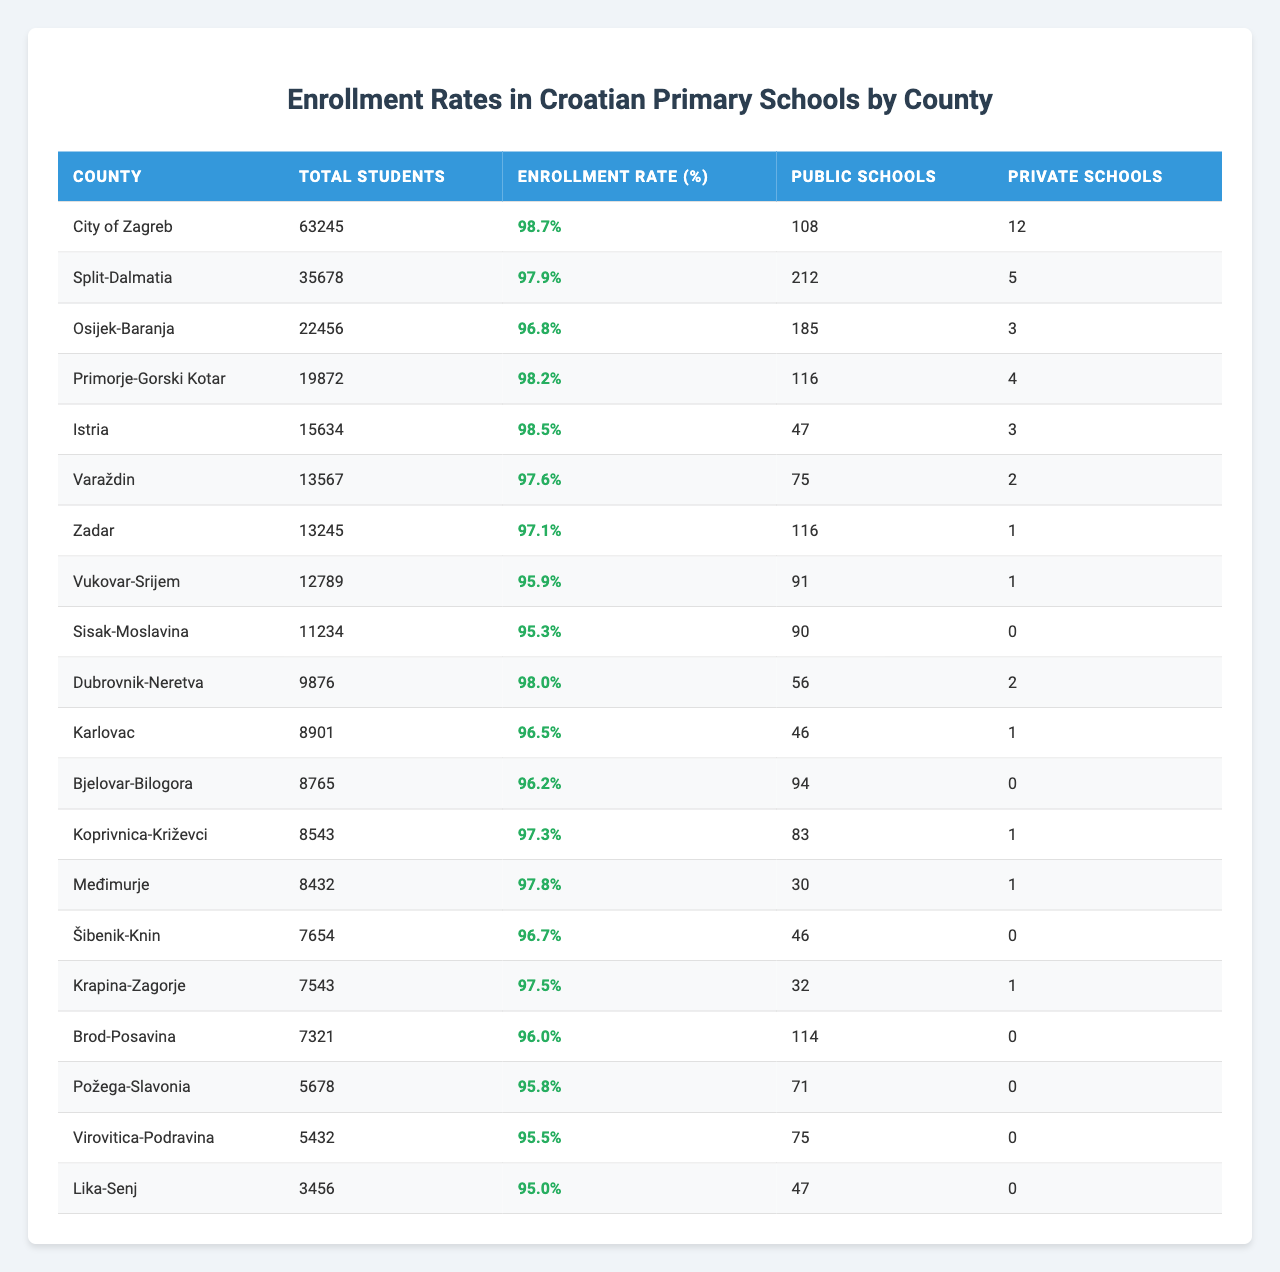What is the enrollment rate for the City of Zagreb? The enrollment rate for the City of Zagreb is listed directly in the table under the "Enrollment Rate (%)" column, which shows a value of 98.7%.
Answer: 98.7% Which county has the highest enrollment rate? By comparing the "Enrollment Rate (%)" values in the table, the City of Zagreb has the highest enrollment rate at 98.7%.
Answer: City of Zagreb What is the total number of students enrolled in Istria? The table shows the total number of students for Istria listed under the "Total Students" column, which is 15,634.
Answer: 15634 Is the enrollment rate in Sisak-Moslavina above 96%? According to the table, the enrollment rate for Sisak-Moslavina is 95.3%, which is below 96%, meaning the statement is false.
Answer: No How many more total students are enrolled in the City of Zagreb compared to Lika-Senj? The total students in the City of Zagreb is 63,245 and for Lika-Senj, it is 3,456. The difference is calculated as 63,245 - 3,456 = 59,789.
Answer: 59789 What is the average enrollment rate for the counties listed in the table? The enrollment rates for the counties need to be summed up: 98.7 + 97.9 + 96.8 + 98.2 + 98.5 + 97.6 + 97.1 + 95.9 + 95.3 + 98.0 + 96.5 + 96.2 + 97.3 + 97.8 + 96.7 + 97.5 + 96.0 + 95.8 + 95.5 + 95.0 = 1948.9. Then dividing by the number of counties (20) provides the average: 1948.9 / 20 = 97.445%.
Answer: 97.445% Does the combined total of private schools in Dubrovnik-Neretva and Koprivnica-Križevci exceed 3? The number of private schools in Dubrovnik-Neretva is 2, and in Koprivnica-Križevci, it is 1. Adding these together gives 2 + 1 = 3, which does not exceed 3.
Answer: No Which counties have an enrollment rate below 96%? By reviewing the "Enrollment Rate (%)" column, the counties with rates below 96% are: Vukovar-Srijem (95.9%), Sisak-Moslavina (95.3%), Brod-Posavina (96.0%), Požega-Slavonia (95.8%), Virovitica-Podravina (95.5%), and Lika-Senj (95.0%).
Answer: Vukovar-Srijem, Sisak-Moslavina, Brod-Posavina, Požega-Slavonia, Virovitica-Podravina, Lika-Senj Calculate the difference in the number of public schools between Split-Dalmatia and Međimurje. Split-Dalmatia has 212 public schools, while Međimurje has 30. The difference is calculated as 212 - 30 = 182.
Answer: 182 